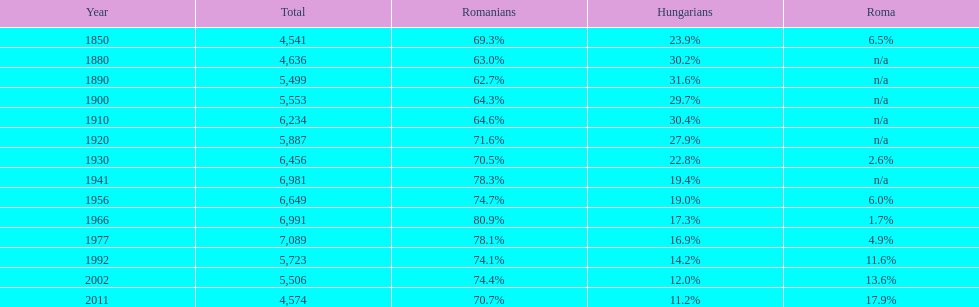On how many occasions was the total population 6,000 or greater? 6. 